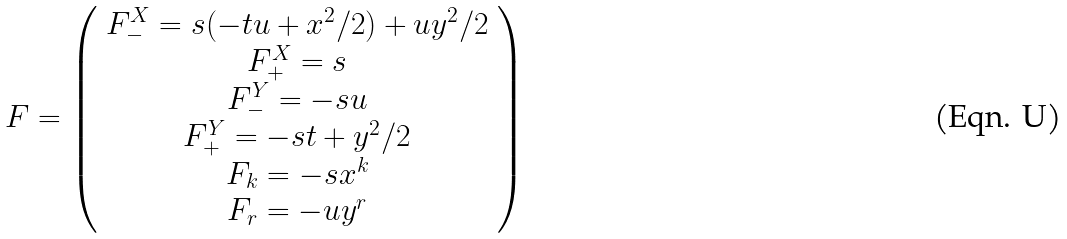Convert formula to latex. <formula><loc_0><loc_0><loc_500><loc_500>F = \left ( \begin{array} { c } F _ { - } ^ { X } = s ( - t u + x ^ { 2 } / 2 ) + u y ^ { 2 } / 2 \\ F _ { + } ^ { X } = s \\ F _ { - } ^ { Y } = - s u \\ F _ { + } ^ { Y } = - s t + y ^ { 2 } / 2 \\ F _ { k } = - s x ^ { k } \\ F _ { r } = - u y ^ { r } \end{array} \right )</formula> 